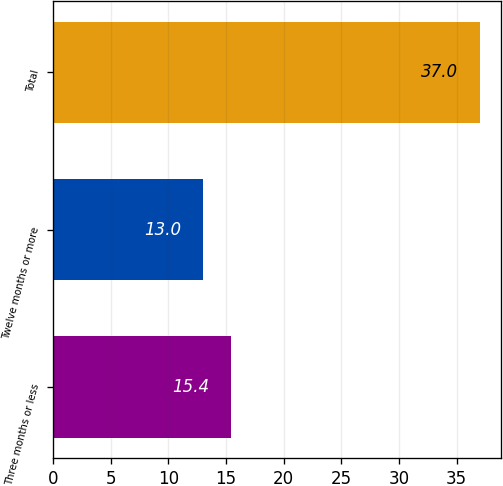<chart> <loc_0><loc_0><loc_500><loc_500><bar_chart><fcel>Three months or less<fcel>Twelve months or more<fcel>Total<nl><fcel>15.4<fcel>13<fcel>37<nl></chart> 